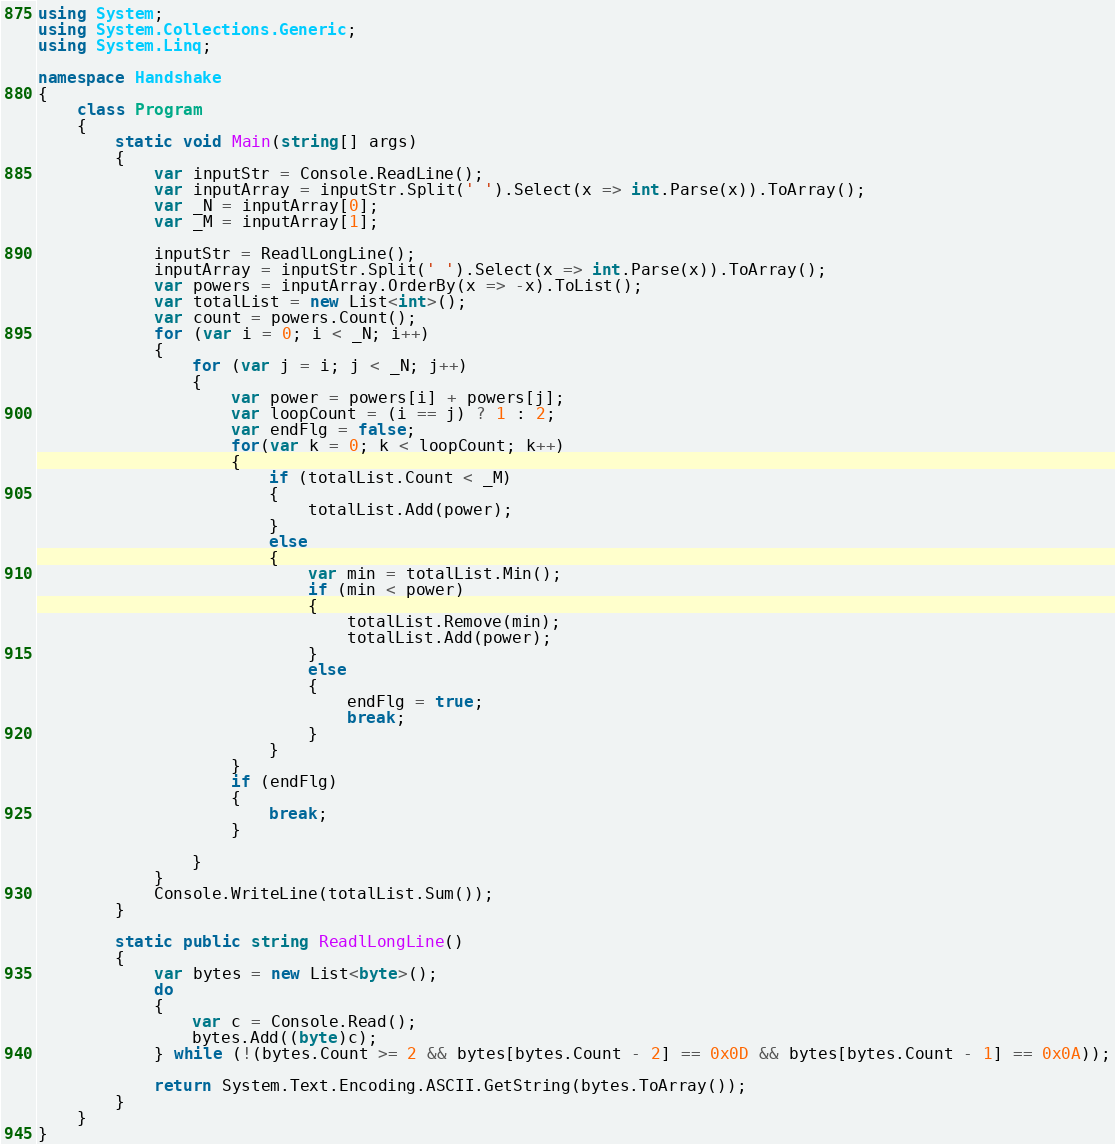Convert code to text. <code><loc_0><loc_0><loc_500><loc_500><_C#_>using System;
using System.Collections.Generic;
using System.Linq;

namespace Handshake
{
    class Program
    {
        static void Main(string[] args)
        {
            var inputStr = Console.ReadLine();
            var inputArray = inputStr.Split(' ').Select(x => int.Parse(x)).ToArray();
            var _N = inputArray[0];
            var _M = inputArray[1];

            inputStr = ReadlLongLine();
            inputArray = inputStr.Split(' ').Select(x => int.Parse(x)).ToArray();
            var powers = inputArray.OrderBy(x => -x).ToList();
            var totalList = new List<int>();
            var count = powers.Count();
            for (var i = 0; i < _N; i++)
            {
                for (var j = i; j < _N; j++)
                {
                    var power = powers[i] + powers[j];
                    var loopCount = (i == j) ? 1 : 2;
                    var endFlg = false;
                    for(var k = 0; k < loopCount; k++)
                    {
                        if (totalList.Count < _M)
                        {
                            totalList.Add(power);
                        }
                        else
                        {
                            var min = totalList.Min();
                            if (min < power)
                            {
                                totalList.Remove(min);
                                totalList.Add(power);
                            }
                            else
                            {
                                endFlg = true;
                                break;
                            }
                        }
                    }
                    if (endFlg)
                    {
                        break;
                    }

                }
            }
            Console.WriteLine(totalList.Sum());
        }

        static public string ReadlLongLine()
        {
            var bytes = new List<byte>();
            do
            {
                var c = Console.Read();
                bytes.Add((byte)c);
            } while (!(bytes.Count >= 2 && bytes[bytes.Count - 2] == 0x0D && bytes[bytes.Count - 1] == 0x0A));

            return System.Text.Encoding.ASCII.GetString(bytes.ToArray());
        }
    }
}
</code> 